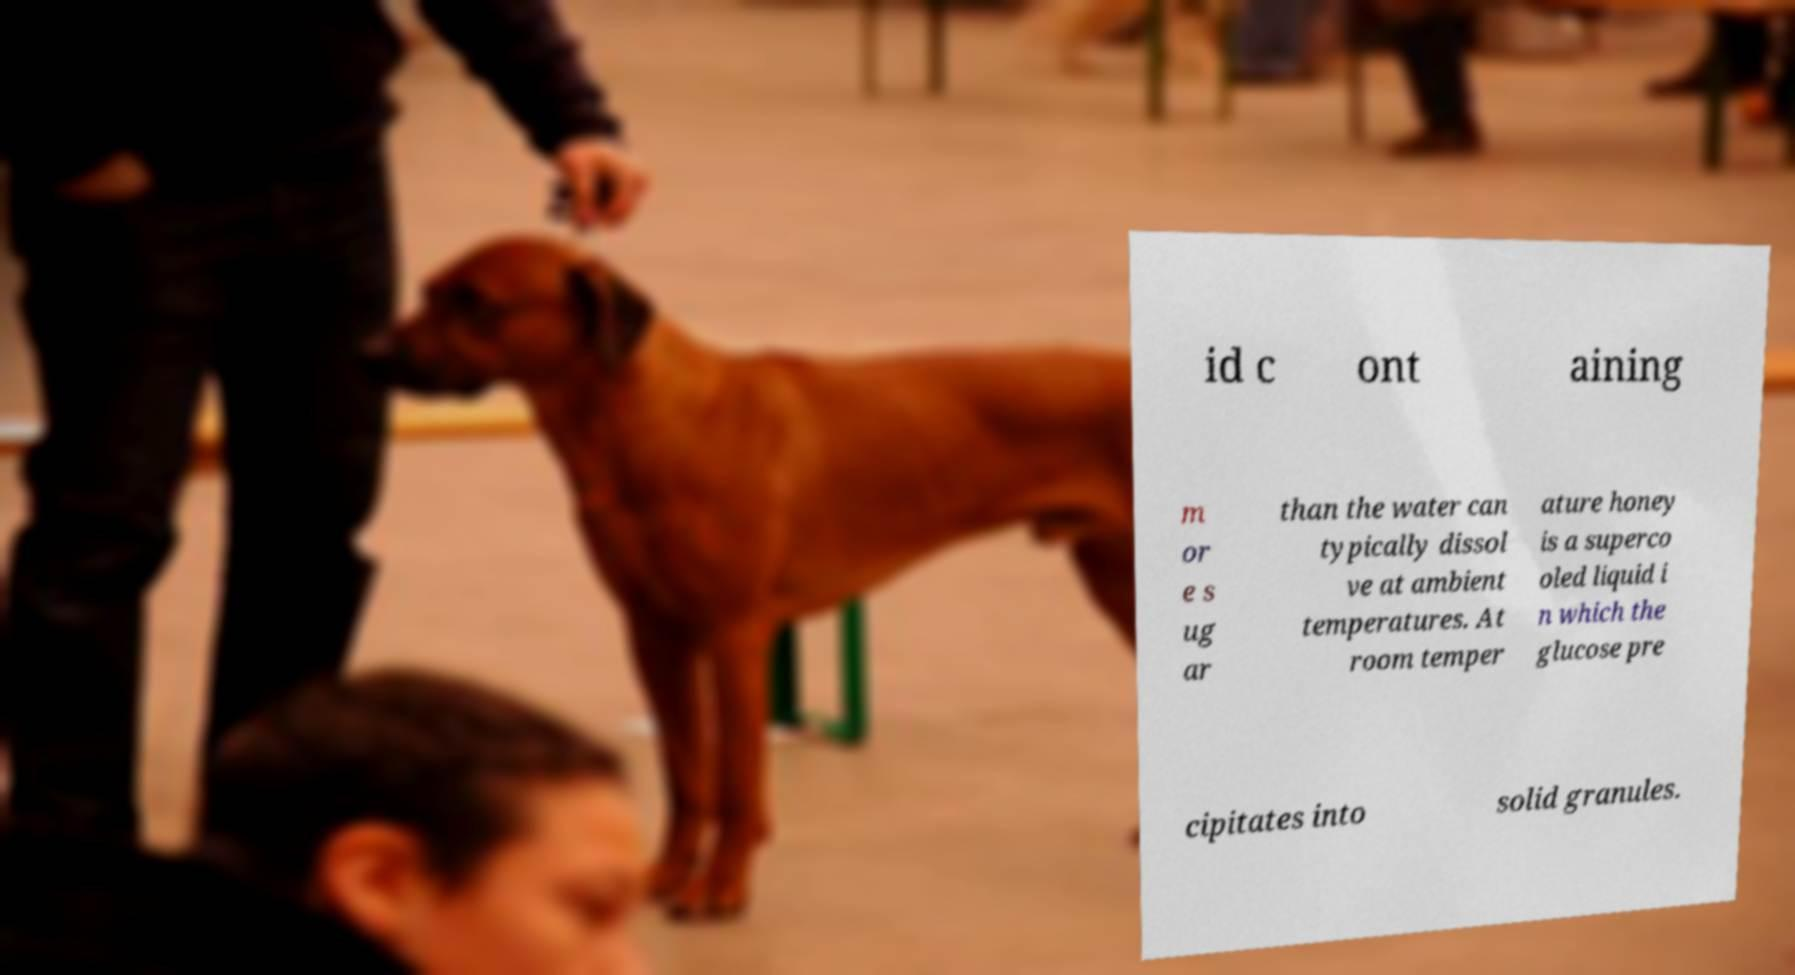I need the written content from this picture converted into text. Can you do that? id c ont aining m or e s ug ar than the water can typically dissol ve at ambient temperatures. At room temper ature honey is a superco oled liquid i n which the glucose pre cipitates into solid granules. 